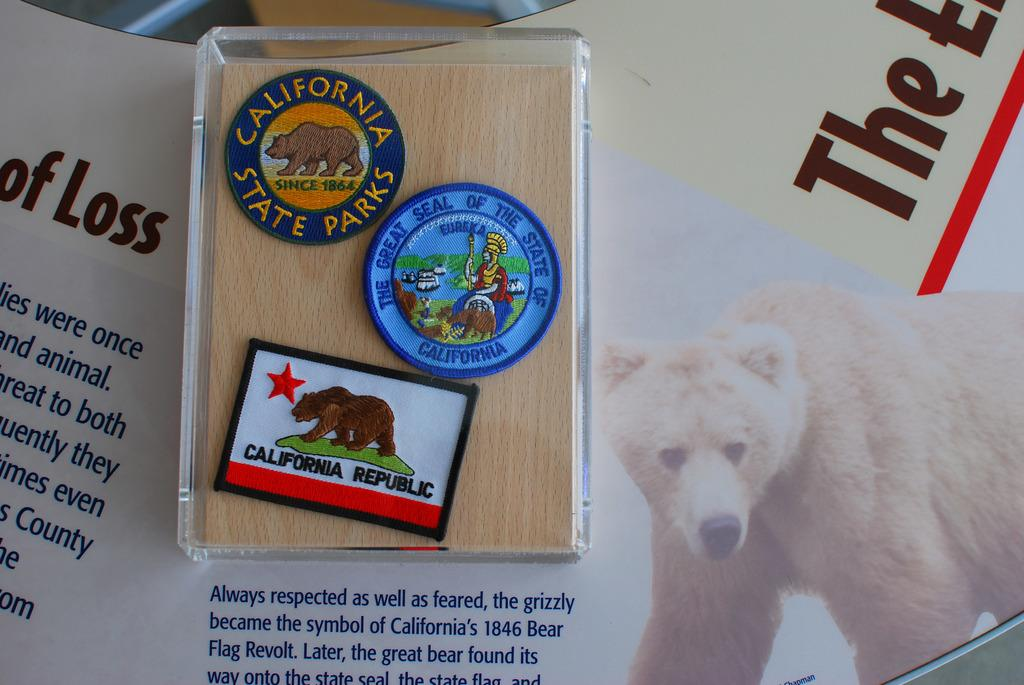How many badges are in the box in the image? There are three badges in a box in the image. Where is the box with the badges located? The box is placed on a table in the image. What can be seen on the table besides the box with badges? The table has posters of animals and texts in the image. Can you see any feet walking on the street in the image? There is no reference to feet or a street in the image, so it is not possible to answer that question. 